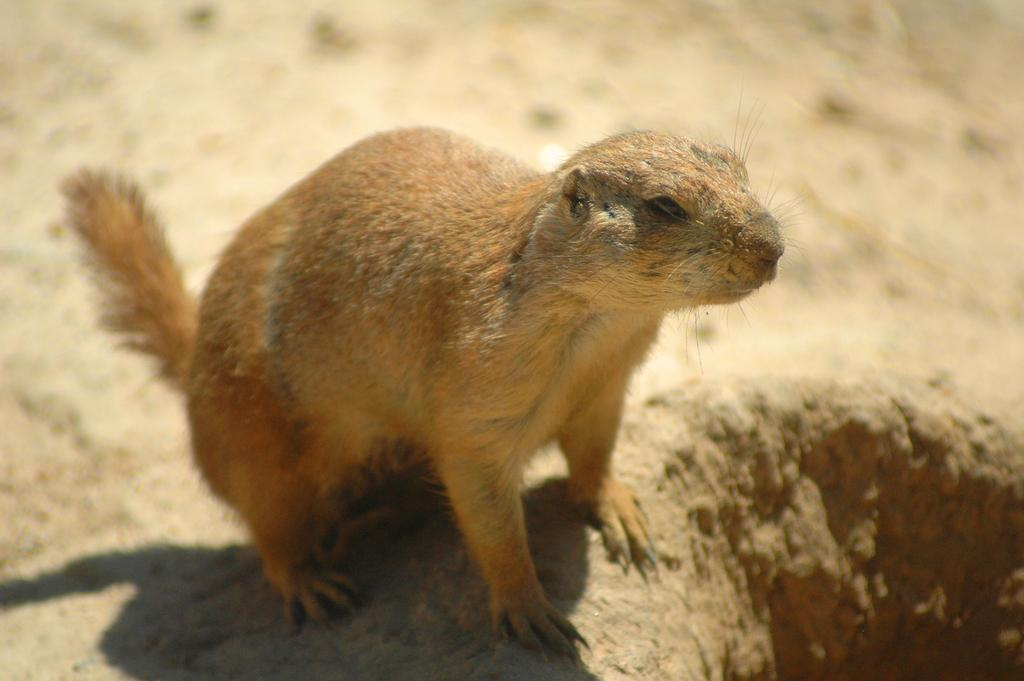Where was the image taken? The image was taken outside. What is the main subject in the center of the image? There is an animal standing in the center of the image. Can you describe the background of the image? The background of the image is blurry. What reason does the animal have for holding a lock in the image? There is no lock present in the image, and therefore no reason for the animal to hold one. 